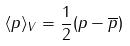<formula> <loc_0><loc_0><loc_500><loc_500>\langle p \rangle _ { V } = \frac { 1 } { 2 } ( p - \overline { p } )</formula> 